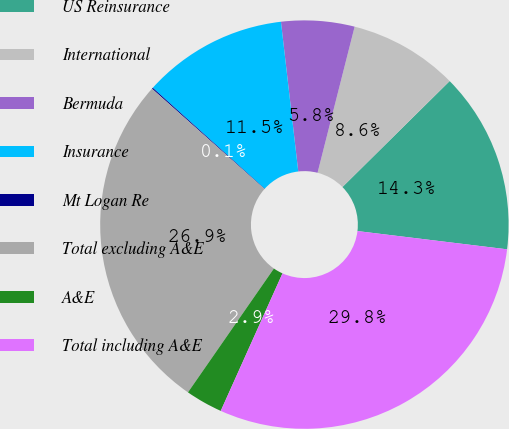Convert chart. <chart><loc_0><loc_0><loc_500><loc_500><pie_chart><fcel>US Reinsurance<fcel>International<fcel>Bermuda<fcel>Insurance<fcel>Mt Logan Re<fcel>Total excluding A&E<fcel>A&E<fcel>Total including A&E<nl><fcel>14.34%<fcel>8.64%<fcel>5.79%<fcel>11.49%<fcel>0.09%<fcel>26.94%<fcel>2.94%<fcel>29.79%<nl></chart> 